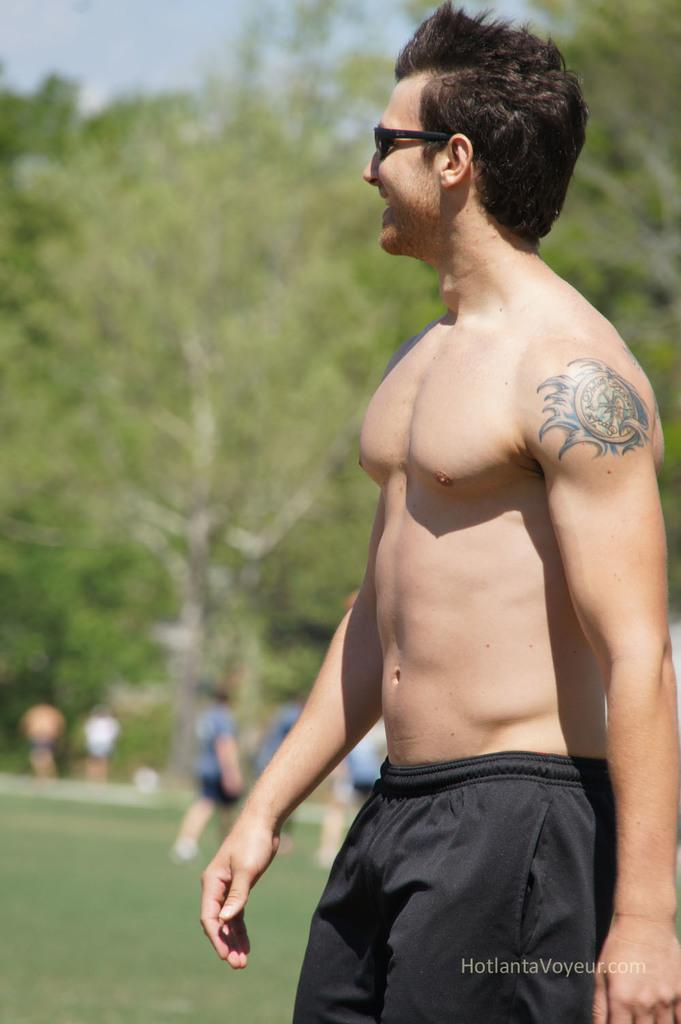Who is the main subject in the image? There is a man in the image. Where is the man positioned in the image? The man is positioned towards the right side of the image. What is the man wearing? The man is wearing black shorts. What can be seen in the background of the image? There are people, grass, and trees in the background of the image. What type of brass instrument is the man playing in the image? There is no brass instrument present in the image; the man is simply positioned towards the right side of the image and wearing black shorts. 